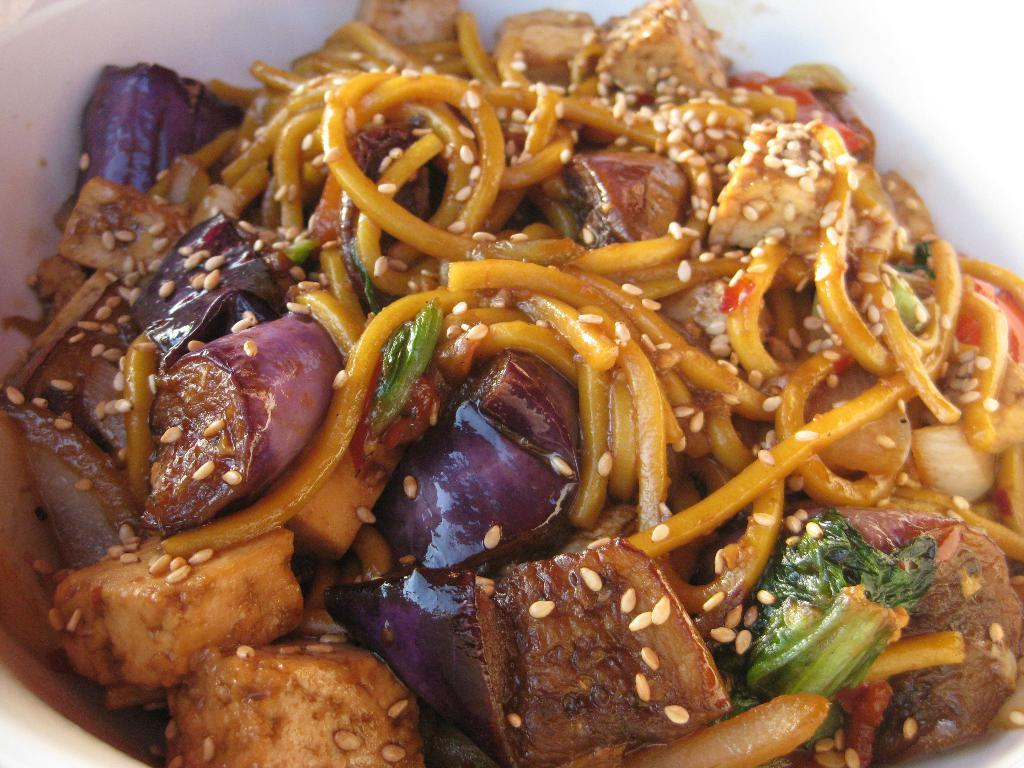What is the main subject of the image? The main subject of the image is food. How is the food presented in the image? The food is in a bowl. What type of police act is being performed in the image? There is no police act or presence in the image; it features food in a bowl. What kind of structure is depicted in the image? The image does not show any structure; it only features food in a bowl. 